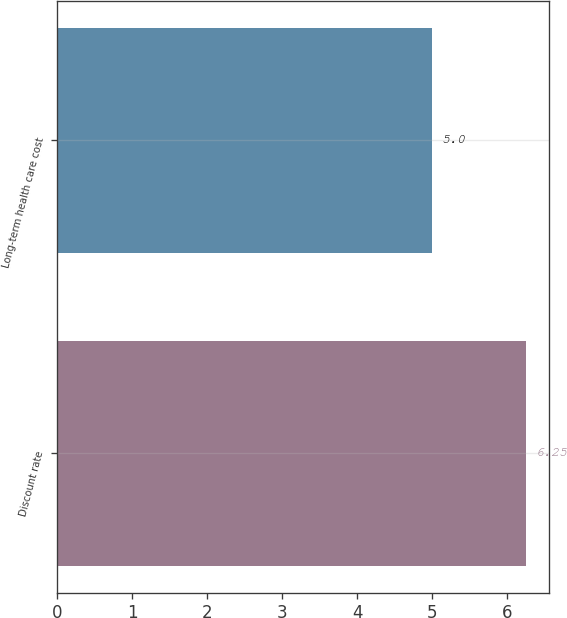Convert chart to OTSL. <chart><loc_0><loc_0><loc_500><loc_500><bar_chart><fcel>Discount rate<fcel>Long-term health care cost<nl><fcel>6.25<fcel>5<nl></chart> 